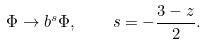Convert formula to latex. <formula><loc_0><loc_0><loc_500><loc_500>\Phi \to b ^ { s } \Phi , \quad s = - \frac { 3 - z } { 2 } .</formula> 